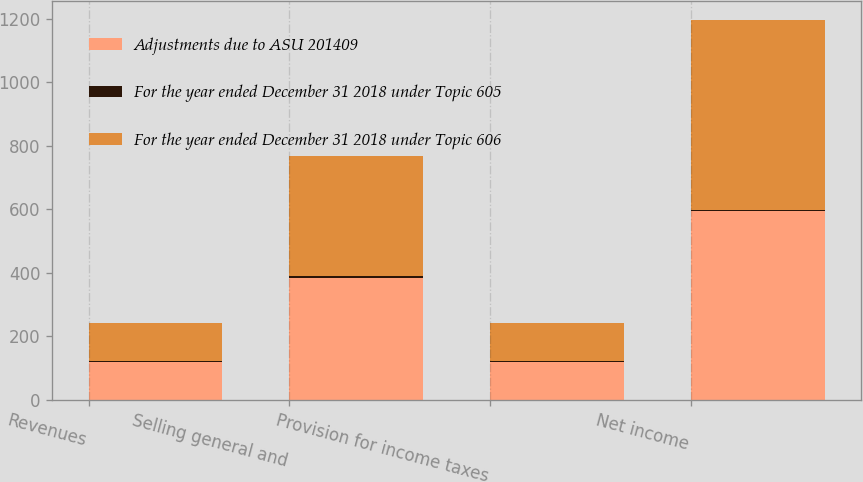Convert chart to OTSL. <chart><loc_0><loc_0><loc_500><loc_500><stacked_bar_chart><ecel><fcel>Revenues<fcel>Selling general and<fcel>Provision for income taxes<fcel>Net income<nl><fcel>Adjustments due to ASU 201409<fcel>120.25<fcel>384<fcel>119.5<fcel>594.2<nl><fcel>For the year ended December 31 2018 under Topic 605<fcel>0.7<fcel>5.3<fcel>1.5<fcel>4.5<nl><fcel>For the year ended December 31 2018 under Topic 606<fcel>120.25<fcel>378.7<fcel>121<fcel>598.7<nl></chart> 